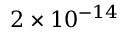Convert formula to latex. <formula><loc_0><loc_0><loc_500><loc_500>2 \times 1 0 ^ { - 1 4 }</formula> 